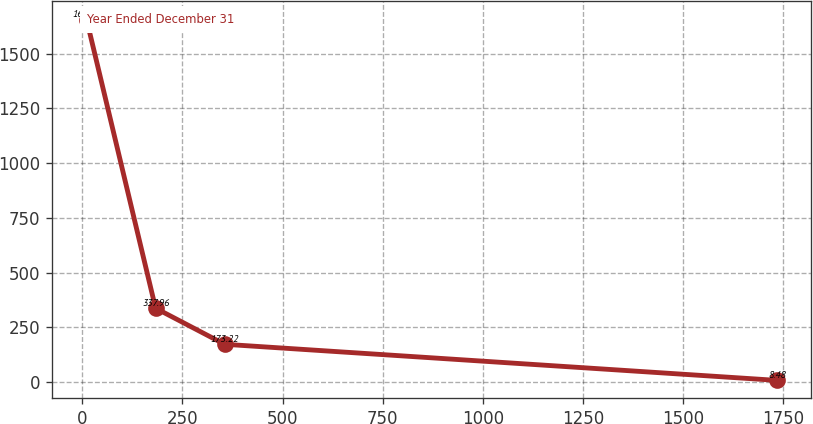Convert chart to OTSL. <chart><loc_0><loc_0><loc_500><loc_500><line_chart><ecel><fcel>Year Ended December 31<nl><fcel>10.49<fcel>1655.9<nl><fcel>182.85<fcel>337.96<nl><fcel>355.21<fcel>173.22<nl><fcel>1734.04<fcel>8.48<nl></chart> 